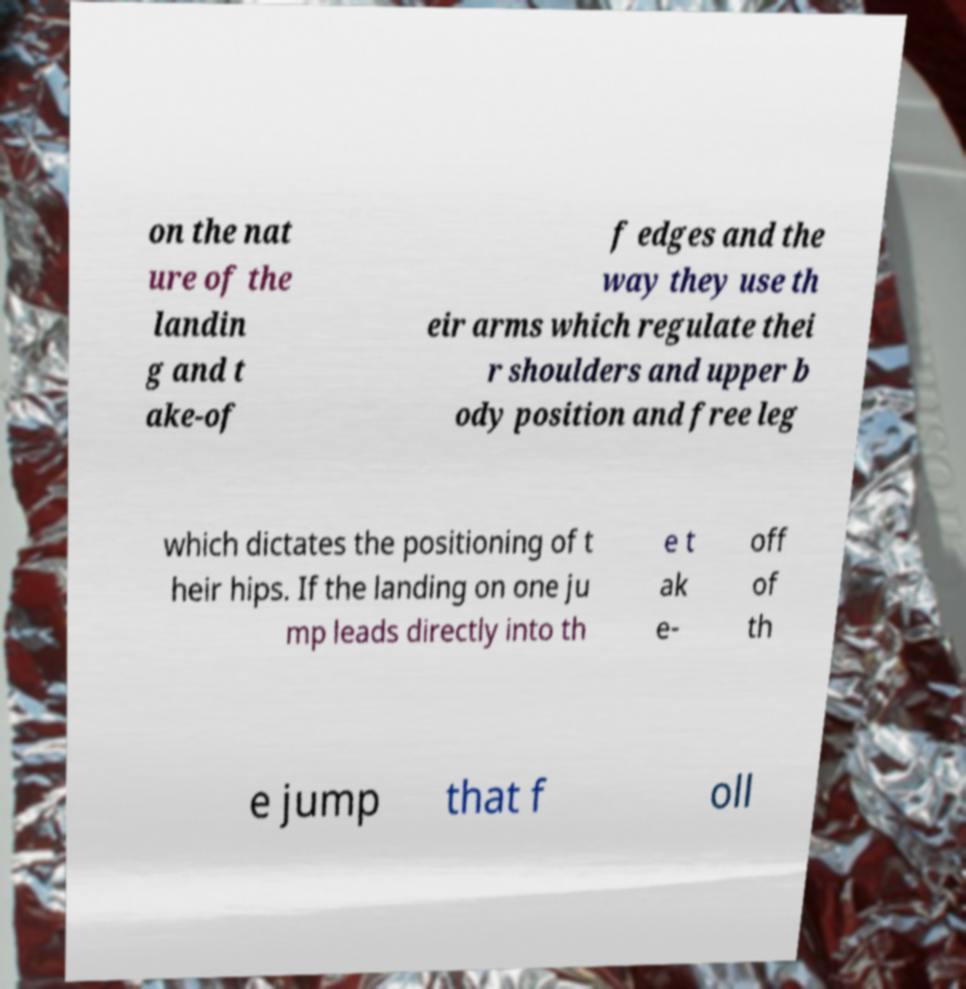Please identify and transcribe the text found in this image. on the nat ure of the landin g and t ake-of f edges and the way they use th eir arms which regulate thei r shoulders and upper b ody position and free leg which dictates the positioning of t heir hips. If the landing on one ju mp leads directly into th e t ak e- off of th e jump that f oll 